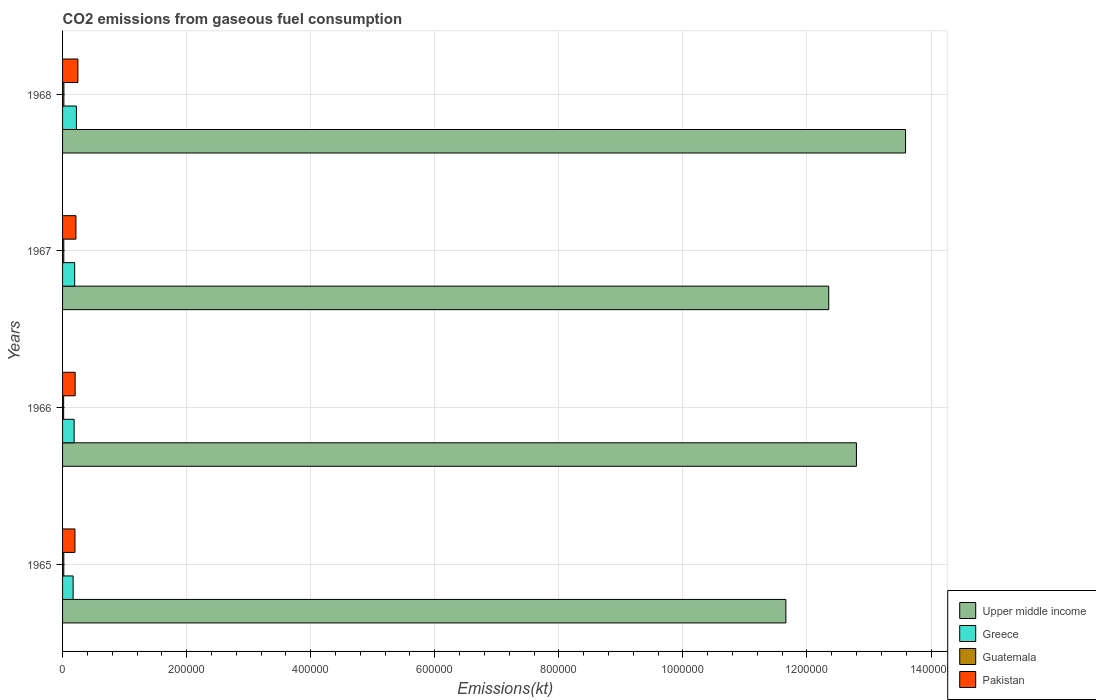How many different coloured bars are there?
Give a very brief answer. 4. How many groups of bars are there?
Your answer should be very brief. 4. What is the label of the 2nd group of bars from the top?
Your response must be concise. 1967. In how many cases, is the number of bars for a given year not equal to the number of legend labels?
Keep it short and to the point. 0. What is the amount of CO2 emitted in Guatemala in 1965?
Make the answer very short. 1976.51. Across all years, what is the maximum amount of CO2 emitted in Greece?
Keep it short and to the point. 2.23e+04. Across all years, what is the minimum amount of CO2 emitted in Guatemala?
Provide a short and direct response. 1741.83. In which year was the amount of CO2 emitted in Guatemala maximum?
Your response must be concise. 1968. In which year was the amount of CO2 emitted in Guatemala minimum?
Ensure brevity in your answer.  1966. What is the total amount of CO2 emitted in Guatemala in the graph?
Keep it short and to the point. 7843.71. What is the difference between the amount of CO2 emitted in Upper middle income in 1965 and that in 1967?
Your response must be concise. -6.91e+04. What is the difference between the amount of CO2 emitted in Pakistan in 1966 and the amount of CO2 emitted in Upper middle income in 1965?
Provide a short and direct response. -1.15e+06. What is the average amount of CO2 emitted in Upper middle income per year?
Your answer should be compact. 1.26e+06. In the year 1967, what is the difference between the amount of CO2 emitted in Upper middle income and amount of CO2 emitted in Greece?
Ensure brevity in your answer.  1.22e+06. What is the ratio of the amount of CO2 emitted in Pakistan in 1965 to that in 1966?
Offer a very short reply. 0.98. Is the amount of CO2 emitted in Upper middle income in 1965 less than that in 1968?
Your answer should be compact. Yes. Is the difference between the amount of CO2 emitted in Upper middle income in 1966 and 1968 greater than the difference between the amount of CO2 emitted in Greece in 1966 and 1968?
Your answer should be compact. No. What is the difference between the highest and the second highest amount of CO2 emitted in Greece?
Keep it short and to the point. 2786.92. What is the difference between the highest and the lowest amount of CO2 emitted in Greece?
Offer a terse response. 5295.15. In how many years, is the amount of CO2 emitted in Greece greater than the average amount of CO2 emitted in Greece taken over all years?
Keep it short and to the point. 2. Is the sum of the amount of CO2 emitted in Guatemala in 1965 and 1966 greater than the maximum amount of CO2 emitted in Upper middle income across all years?
Give a very brief answer. No. Is it the case that in every year, the sum of the amount of CO2 emitted in Upper middle income and amount of CO2 emitted in Greece is greater than the sum of amount of CO2 emitted in Pakistan and amount of CO2 emitted in Guatemala?
Offer a terse response. Yes. What does the 4th bar from the bottom in 1968 represents?
Ensure brevity in your answer.  Pakistan. How many bars are there?
Your response must be concise. 16. Are all the bars in the graph horizontal?
Provide a short and direct response. Yes. How many years are there in the graph?
Your response must be concise. 4. Does the graph contain grids?
Give a very brief answer. Yes. Where does the legend appear in the graph?
Offer a very short reply. Bottom right. What is the title of the graph?
Provide a short and direct response. CO2 emissions from gaseous fuel consumption. Does "Lao PDR" appear as one of the legend labels in the graph?
Your response must be concise. No. What is the label or title of the X-axis?
Give a very brief answer. Emissions(kt). What is the Emissions(kt) of Upper middle income in 1965?
Give a very brief answer. 1.17e+06. What is the Emissions(kt) in Greece in 1965?
Provide a short and direct response. 1.70e+04. What is the Emissions(kt) of Guatemala in 1965?
Give a very brief answer. 1976.51. What is the Emissions(kt) of Pakistan in 1965?
Your answer should be compact. 2.00e+04. What is the Emissions(kt) of Upper middle income in 1966?
Provide a short and direct response. 1.28e+06. What is the Emissions(kt) of Greece in 1966?
Make the answer very short. 1.87e+04. What is the Emissions(kt) in Guatemala in 1966?
Provide a short and direct response. 1741.83. What is the Emissions(kt) of Pakistan in 1966?
Offer a terse response. 2.03e+04. What is the Emissions(kt) in Upper middle income in 1967?
Provide a succinct answer. 1.24e+06. What is the Emissions(kt) of Greece in 1967?
Your response must be concise. 1.95e+04. What is the Emissions(kt) in Guatemala in 1967?
Keep it short and to the point. 1983.85. What is the Emissions(kt) of Pakistan in 1967?
Provide a succinct answer. 2.16e+04. What is the Emissions(kt) in Upper middle income in 1968?
Your answer should be very brief. 1.36e+06. What is the Emissions(kt) of Greece in 1968?
Make the answer very short. 2.23e+04. What is the Emissions(kt) in Guatemala in 1968?
Your answer should be compact. 2141.53. What is the Emissions(kt) of Pakistan in 1968?
Provide a short and direct response. 2.47e+04. Across all years, what is the maximum Emissions(kt) of Upper middle income?
Your answer should be very brief. 1.36e+06. Across all years, what is the maximum Emissions(kt) in Greece?
Offer a terse response. 2.23e+04. Across all years, what is the maximum Emissions(kt) in Guatemala?
Keep it short and to the point. 2141.53. Across all years, what is the maximum Emissions(kt) of Pakistan?
Your answer should be compact. 2.47e+04. Across all years, what is the minimum Emissions(kt) in Upper middle income?
Your response must be concise. 1.17e+06. Across all years, what is the minimum Emissions(kt) in Greece?
Ensure brevity in your answer.  1.70e+04. Across all years, what is the minimum Emissions(kt) of Guatemala?
Provide a succinct answer. 1741.83. Across all years, what is the minimum Emissions(kt) in Pakistan?
Keep it short and to the point. 2.00e+04. What is the total Emissions(kt) of Upper middle income in the graph?
Your answer should be very brief. 5.04e+06. What is the total Emissions(kt) of Greece in the graph?
Ensure brevity in your answer.  7.75e+04. What is the total Emissions(kt) of Guatemala in the graph?
Your answer should be compact. 7843.71. What is the total Emissions(kt) of Pakistan in the graph?
Give a very brief answer. 8.66e+04. What is the difference between the Emissions(kt) in Upper middle income in 1965 and that in 1966?
Offer a very short reply. -1.14e+05. What is the difference between the Emissions(kt) in Greece in 1965 and that in 1966?
Make the answer very short. -1624.48. What is the difference between the Emissions(kt) of Guatemala in 1965 and that in 1966?
Provide a short and direct response. 234.69. What is the difference between the Emissions(kt) in Pakistan in 1965 and that in 1966?
Provide a succinct answer. -352.03. What is the difference between the Emissions(kt) of Upper middle income in 1965 and that in 1967?
Provide a succinct answer. -6.91e+04. What is the difference between the Emissions(kt) of Greece in 1965 and that in 1967?
Provide a short and direct response. -2508.23. What is the difference between the Emissions(kt) of Guatemala in 1965 and that in 1967?
Ensure brevity in your answer.  -7.33. What is the difference between the Emissions(kt) of Pakistan in 1965 and that in 1967?
Offer a terse response. -1598.81. What is the difference between the Emissions(kt) in Upper middle income in 1965 and that in 1968?
Keep it short and to the point. -1.93e+05. What is the difference between the Emissions(kt) in Greece in 1965 and that in 1968?
Your answer should be compact. -5295.15. What is the difference between the Emissions(kt) of Guatemala in 1965 and that in 1968?
Keep it short and to the point. -165.01. What is the difference between the Emissions(kt) in Pakistan in 1965 and that in 1968?
Ensure brevity in your answer.  -4763.43. What is the difference between the Emissions(kt) in Upper middle income in 1966 and that in 1967?
Your answer should be compact. 4.46e+04. What is the difference between the Emissions(kt) of Greece in 1966 and that in 1967?
Your response must be concise. -883.75. What is the difference between the Emissions(kt) of Guatemala in 1966 and that in 1967?
Make the answer very short. -242.02. What is the difference between the Emissions(kt) in Pakistan in 1966 and that in 1967?
Give a very brief answer. -1246.78. What is the difference between the Emissions(kt) in Upper middle income in 1966 and that in 1968?
Make the answer very short. -7.92e+04. What is the difference between the Emissions(kt) of Greece in 1966 and that in 1968?
Offer a very short reply. -3670.67. What is the difference between the Emissions(kt) of Guatemala in 1966 and that in 1968?
Keep it short and to the point. -399.7. What is the difference between the Emissions(kt) in Pakistan in 1966 and that in 1968?
Offer a terse response. -4411.4. What is the difference between the Emissions(kt) of Upper middle income in 1967 and that in 1968?
Your response must be concise. -1.24e+05. What is the difference between the Emissions(kt) of Greece in 1967 and that in 1968?
Offer a terse response. -2786.92. What is the difference between the Emissions(kt) of Guatemala in 1967 and that in 1968?
Your answer should be compact. -157.68. What is the difference between the Emissions(kt) in Pakistan in 1967 and that in 1968?
Provide a succinct answer. -3164.62. What is the difference between the Emissions(kt) of Upper middle income in 1965 and the Emissions(kt) of Greece in 1966?
Your response must be concise. 1.15e+06. What is the difference between the Emissions(kt) of Upper middle income in 1965 and the Emissions(kt) of Guatemala in 1966?
Your answer should be compact. 1.16e+06. What is the difference between the Emissions(kt) of Upper middle income in 1965 and the Emissions(kt) of Pakistan in 1966?
Give a very brief answer. 1.15e+06. What is the difference between the Emissions(kt) in Greece in 1965 and the Emissions(kt) in Guatemala in 1966?
Provide a short and direct response. 1.53e+04. What is the difference between the Emissions(kt) in Greece in 1965 and the Emissions(kt) in Pakistan in 1966?
Give a very brief answer. -3300.3. What is the difference between the Emissions(kt) of Guatemala in 1965 and the Emissions(kt) of Pakistan in 1966?
Your answer should be compact. -1.83e+04. What is the difference between the Emissions(kt) in Upper middle income in 1965 and the Emissions(kt) in Greece in 1967?
Offer a very short reply. 1.15e+06. What is the difference between the Emissions(kt) of Upper middle income in 1965 and the Emissions(kt) of Guatemala in 1967?
Make the answer very short. 1.16e+06. What is the difference between the Emissions(kt) of Upper middle income in 1965 and the Emissions(kt) of Pakistan in 1967?
Offer a terse response. 1.14e+06. What is the difference between the Emissions(kt) in Greece in 1965 and the Emissions(kt) in Guatemala in 1967?
Provide a succinct answer. 1.50e+04. What is the difference between the Emissions(kt) in Greece in 1965 and the Emissions(kt) in Pakistan in 1967?
Give a very brief answer. -4547.08. What is the difference between the Emissions(kt) in Guatemala in 1965 and the Emissions(kt) in Pakistan in 1967?
Provide a short and direct response. -1.96e+04. What is the difference between the Emissions(kt) in Upper middle income in 1965 and the Emissions(kt) in Greece in 1968?
Make the answer very short. 1.14e+06. What is the difference between the Emissions(kt) in Upper middle income in 1965 and the Emissions(kt) in Guatemala in 1968?
Make the answer very short. 1.16e+06. What is the difference between the Emissions(kt) in Upper middle income in 1965 and the Emissions(kt) in Pakistan in 1968?
Your response must be concise. 1.14e+06. What is the difference between the Emissions(kt) in Greece in 1965 and the Emissions(kt) in Guatemala in 1968?
Your answer should be very brief. 1.49e+04. What is the difference between the Emissions(kt) in Greece in 1965 and the Emissions(kt) in Pakistan in 1968?
Provide a succinct answer. -7711.7. What is the difference between the Emissions(kt) of Guatemala in 1965 and the Emissions(kt) of Pakistan in 1968?
Your response must be concise. -2.28e+04. What is the difference between the Emissions(kt) in Upper middle income in 1966 and the Emissions(kt) in Greece in 1967?
Offer a very short reply. 1.26e+06. What is the difference between the Emissions(kt) of Upper middle income in 1966 and the Emissions(kt) of Guatemala in 1967?
Your answer should be compact. 1.28e+06. What is the difference between the Emissions(kt) of Upper middle income in 1966 and the Emissions(kt) of Pakistan in 1967?
Your answer should be compact. 1.26e+06. What is the difference between the Emissions(kt) in Greece in 1966 and the Emissions(kt) in Guatemala in 1967?
Your answer should be very brief. 1.67e+04. What is the difference between the Emissions(kt) of Greece in 1966 and the Emissions(kt) of Pakistan in 1967?
Provide a short and direct response. -2922.6. What is the difference between the Emissions(kt) in Guatemala in 1966 and the Emissions(kt) in Pakistan in 1967?
Offer a very short reply. -1.98e+04. What is the difference between the Emissions(kt) of Upper middle income in 1966 and the Emissions(kt) of Greece in 1968?
Keep it short and to the point. 1.26e+06. What is the difference between the Emissions(kt) in Upper middle income in 1966 and the Emissions(kt) in Guatemala in 1968?
Give a very brief answer. 1.28e+06. What is the difference between the Emissions(kt) in Upper middle income in 1966 and the Emissions(kt) in Pakistan in 1968?
Keep it short and to the point. 1.25e+06. What is the difference between the Emissions(kt) in Greece in 1966 and the Emissions(kt) in Guatemala in 1968?
Give a very brief answer. 1.65e+04. What is the difference between the Emissions(kt) in Greece in 1966 and the Emissions(kt) in Pakistan in 1968?
Provide a succinct answer. -6087.22. What is the difference between the Emissions(kt) in Guatemala in 1966 and the Emissions(kt) in Pakistan in 1968?
Ensure brevity in your answer.  -2.30e+04. What is the difference between the Emissions(kt) in Upper middle income in 1967 and the Emissions(kt) in Greece in 1968?
Provide a succinct answer. 1.21e+06. What is the difference between the Emissions(kt) of Upper middle income in 1967 and the Emissions(kt) of Guatemala in 1968?
Your answer should be very brief. 1.23e+06. What is the difference between the Emissions(kt) in Upper middle income in 1967 and the Emissions(kt) in Pakistan in 1968?
Your answer should be compact. 1.21e+06. What is the difference between the Emissions(kt) of Greece in 1967 and the Emissions(kt) of Guatemala in 1968?
Keep it short and to the point. 1.74e+04. What is the difference between the Emissions(kt) of Greece in 1967 and the Emissions(kt) of Pakistan in 1968?
Your answer should be compact. -5203.47. What is the difference between the Emissions(kt) in Guatemala in 1967 and the Emissions(kt) in Pakistan in 1968?
Your answer should be very brief. -2.28e+04. What is the average Emissions(kt) of Upper middle income per year?
Offer a very short reply. 1.26e+06. What is the average Emissions(kt) of Greece per year?
Your answer should be very brief. 1.94e+04. What is the average Emissions(kt) of Guatemala per year?
Provide a succinct answer. 1960.93. What is the average Emissions(kt) in Pakistan per year?
Your answer should be compact. 2.17e+04. In the year 1965, what is the difference between the Emissions(kt) in Upper middle income and Emissions(kt) in Greece?
Your answer should be very brief. 1.15e+06. In the year 1965, what is the difference between the Emissions(kt) of Upper middle income and Emissions(kt) of Guatemala?
Your response must be concise. 1.16e+06. In the year 1965, what is the difference between the Emissions(kt) in Upper middle income and Emissions(kt) in Pakistan?
Offer a terse response. 1.15e+06. In the year 1965, what is the difference between the Emissions(kt) in Greece and Emissions(kt) in Guatemala?
Provide a succinct answer. 1.50e+04. In the year 1965, what is the difference between the Emissions(kt) of Greece and Emissions(kt) of Pakistan?
Your answer should be very brief. -2948.27. In the year 1965, what is the difference between the Emissions(kt) in Guatemala and Emissions(kt) in Pakistan?
Provide a short and direct response. -1.80e+04. In the year 1966, what is the difference between the Emissions(kt) in Upper middle income and Emissions(kt) in Greece?
Give a very brief answer. 1.26e+06. In the year 1966, what is the difference between the Emissions(kt) of Upper middle income and Emissions(kt) of Guatemala?
Your answer should be compact. 1.28e+06. In the year 1966, what is the difference between the Emissions(kt) of Upper middle income and Emissions(kt) of Pakistan?
Your answer should be very brief. 1.26e+06. In the year 1966, what is the difference between the Emissions(kt) in Greece and Emissions(kt) in Guatemala?
Your answer should be very brief. 1.69e+04. In the year 1966, what is the difference between the Emissions(kt) in Greece and Emissions(kt) in Pakistan?
Give a very brief answer. -1675.82. In the year 1966, what is the difference between the Emissions(kt) of Guatemala and Emissions(kt) of Pakistan?
Your answer should be very brief. -1.86e+04. In the year 1967, what is the difference between the Emissions(kt) in Upper middle income and Emissions(kt) in Greece?
Your answer should be compact. 1.22e+06. In the year 1967, what is the difference between the Emissions(kt) in Upper middle income and Emissions(kt) in Guatemala?
Make the answer very short. 1.23e+06. In the year 1967, what is the difference between the Emissions(kt) of Upper middle income and Emissions(kt) of Pakistan?
Offer a terse response. 1.21e+06. In the year 1967, what is the difference between the Emissions(kt) of Greece and Emissions(kt) of Guatemala?
Give a very brief answer. 1.76e+04. In the year 1967, what is the difference between the Emissions(kt) of Greece and Emissions(kt) of Pakistan?
Give a very brief answer. -2038.85. In the year 1967, what is the difference between the Emissions(kt) of Guatemala and Emissions(kt) of Pakistan?
Provide a short and direct response. -1.96e+04. In the year 1968, what is the difference between the Emissions(kt) of Upper middle income and Emissions(kt) of Greece?
Provide a succinct answer. 1.34e+06. In the year 1968, what is the difference between the Emissions(kt) of Upper middle income and Emissions(kt) of Guatemala?
Offer a very short reply. 1.36e+06. In the year 1968, what is the difference between the Emissions(kt) of Upper middle income and Emissions(kt) of Pakistan?
Your answer should be very brief. 1.33e+06. In the year 1968, what is the difference between the Emissions(kt) in Greece and Emissions(kt) in Guatemala?
Your answer should be very brief. 2.02e+04. In the year 1968, what is the difference between the Emissions(kt) of Greece and Emissions(kt) of Pakistan?
Your answer should be very brief. -2416.55. In the year 1968, what is the difference between the Emissions(kt) in Guatemala and Emissions(kt) in Pakistan?
Your response must be concise. -2.26e+04. What is the ratio of the Emissions(kt) of Upper middle income in 1965 to that in 1966?
Offer a terse response. 0.91. What is the ratio of the Emissions(kt) in Greece in 1965 to that in 1966?
Keep it short and to the point. 0.91. What is the ratio of the Emissions(kt) in Guatemala in 1965 to that in 1966?
Offer a terse response. 1.13. What is the ratio of the Emissions(kt) in Pakistan in 1965 to that in 1966?
Provide a succinct answer. 0.98. What is the ratio of the Emissions(kt) in Upper middle income in 1965 to that in 1967?
Provide a succinct answer. 0.94. What is the ratio of the Emissions(kt) of Greece in 1965 to that in 1967?
Your answer should be very brief. 0.87. What is the ratio of the Emissions(kt) of Pakistan in 1965 to that in 1967?
Make the answer very short. 0.93. What is the ratio of the Emissions(kt) of Upper middle income in 1965 to that in 1968?
Provide a succinct answer. 0.86. What is the ratio of the Emissions(kt) of Greece in 1965 to that in 1968?
Ensure brevity in your answer.  0.76. What is the ratio of the Emissions(kt) of Guatemala in 1965 to that in 1968?
Provide a short and direct response. 0.92. What is the ratio of the Emissions(kt) in Pakistan in 1965 to that in 1968?
Provide a short and direct response. 0.81. What is the ratio of the Emissions(kt) in Upper middle income in 1966 to that in 1967?
Your answer should be compact. 1.04. What is the ratio of the Emissions(kt) of Greece in 1966 to that in 1967?
Offer a very short reply. 0.95. What is the ratio of the Emissions(kt) of Guatemala in 1966 to that in 1967?
Provide a short and direct response. 0.88. What is the ratio of the Emissions(kt) of Pakistan in 1966 to that in 1967?
Your answer should be compact. 0.94. What is the ratio of the Emissions(kt) of Upper middle income in 1966 to that in 1968?
Your answer should be compact. 0.94. What is the ratio of the Emissions(kt) in Greece in 1966 to that in 1968?
Make the answer very short. 0.84. What is the ratio of the Emissions(kt) in Guatemala in 1966 to that in 1968?
Your answer should be very brief. 0.81. What is the ratio of the Emissions(kt) of Pakistan in 1966 to that in 1968?
Keep it short and to the point. 0.82. What is the ratio of the Emissions(kt) of Upper middle income in 1967 to that in 1968?
Offer a very short reply. 0.91. What is the ratio of the Emissions(kt) in Greece in 1967 to that in 1968?
Give a very brief answer. 0.88. What is the ratio of the Emissions(kt) in Guatemala in 1967 to that in 1968?
Keep it short and to the point. 0.93. What is the ratio of the Emissions(kt) of Pakistan in 1967 to that in 1968?
Your answer should be compact. 0.87. What is the difference between the highest and the second highest Emissions(kt) of Upper middle income?
Your answer should be very brief. 7.92e+04. What is the difference between the highest and the second highest Emissions(kt) in Greece?
Your response must be concise. 2786.92. What is the difference between the highest and the second highest Emissions(kt) in Guatemala?
Provide a succinct answer. 157.68. What is the difference between the highest and the second highest Emissions(kt) of Pakistan?
Give a very brief answer. 3164.62. What is the difference between the highest and the lowest Emissions(kt) in Upper middle income?
Give a very brief answer. 1.93e+05. What is the difference between the highest and the lowest Emissions(kt) of Greece?
Keep it short and to the point. 5295.15. What is the difference between the highest and the lowest Emissions(kt) in Guatemala?
Offer a very short reply. 399.7. What is the difference between the highest and the lowest Emissions(kt) in Pakistan?
Your answer should be very brief. 4763.43. 